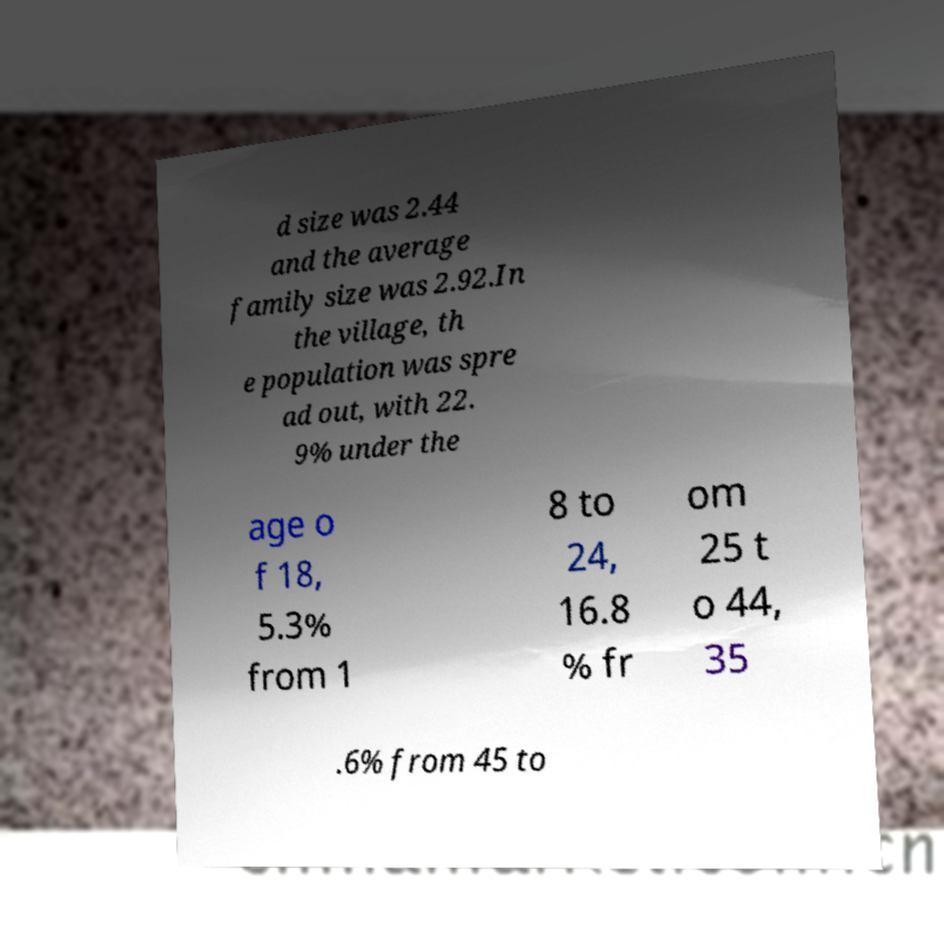Please identify and transcribe the text found in this image. d size was 2.44 and the average family size was 2.92.In the village, th e population was spre ad out, with 22. 9% under the age o f 18, 5.3% from 1 8 to 24, 16.8 % fr om 25 t o 44, 35 .6% from 45 to 